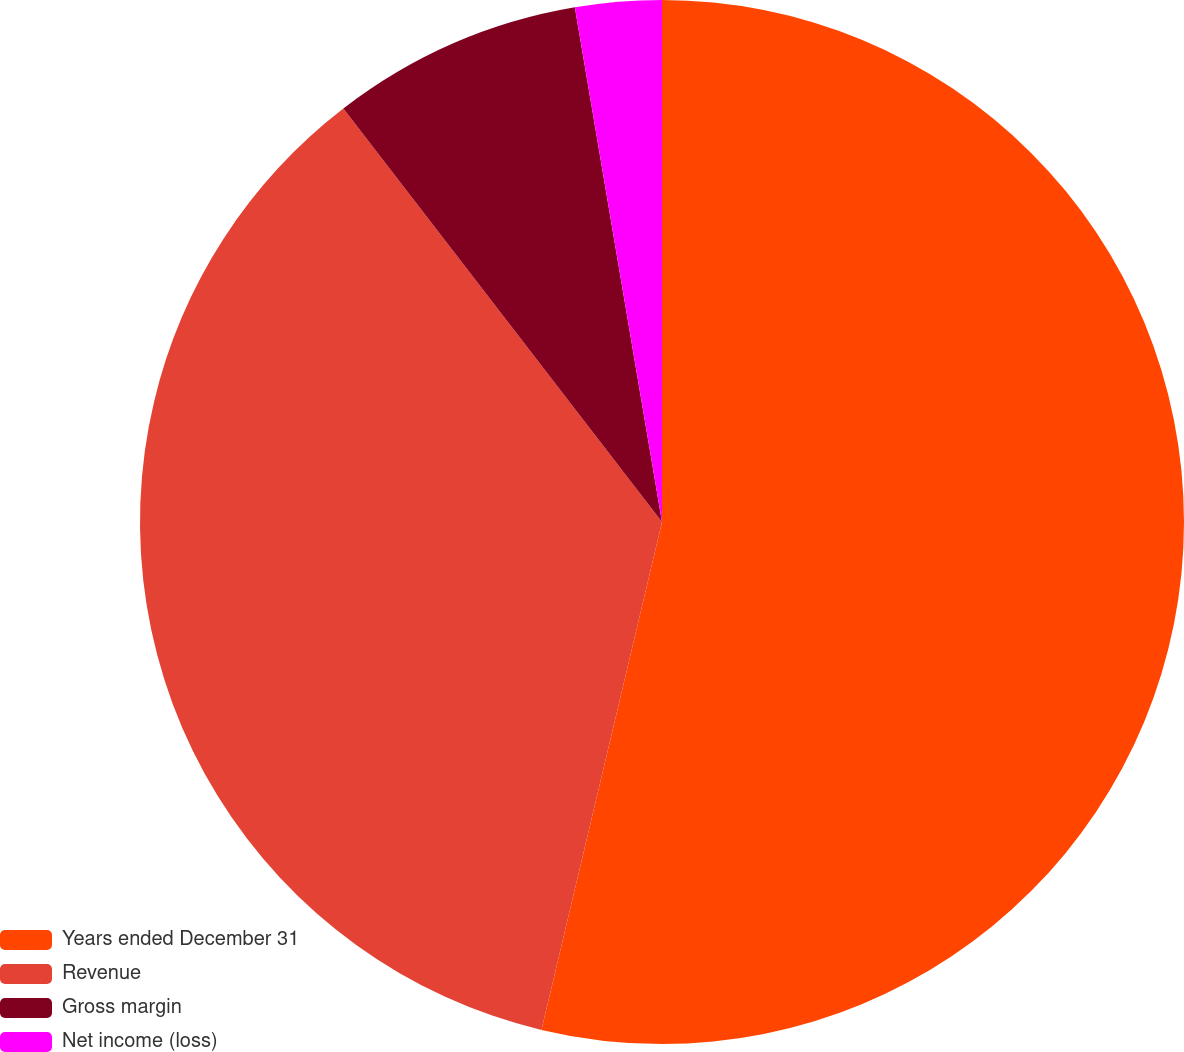Convert chart. <chart><loc_0><loc_0><loc_500><loc_500><pie_chart><fcel>Years ended December 31<fcel>Revenue<fcel>Gross margin<fcel>Net income (loss)<nl><fcel>53.71%<fcel>35.84%<fcel>7.78%<fcel>2.67%<nl></chart> 